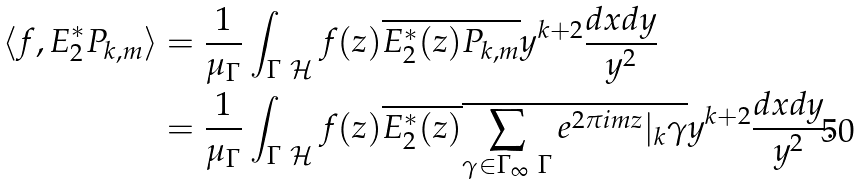<formula> <loc_0><loc_0><loc_500><loc_500>\langle f , E _ { 2 } ^ { * } P _ { k , m } \rangle & = \frac { 1 } { \mu _ { \Gamma } } \int _ { \Gamma \ \mathcal { H } } f ( z ) \overline { E _ { 2 } ^ { * } ( z ) P _ { k , m } } y ^ { k + 2 } \frac { d x d y } { y ^ { 2 } } \\ & = \frac { 1 } { \mu _ { \Gamma } } \int _ { \Gamma \ \mathcal { H } } f ( z ) \overline { E _ { 2 } ^ { * } ( z ) } \overline { \sum _ { \gamma \in \Gamma _ { \infty } \ \Gamma } e ^ { 2 \pi i m z } | _ { k } \gamma } y ^ { k + 2 } \frac { d x d y } { y ^ { 2 } } .</formula> 